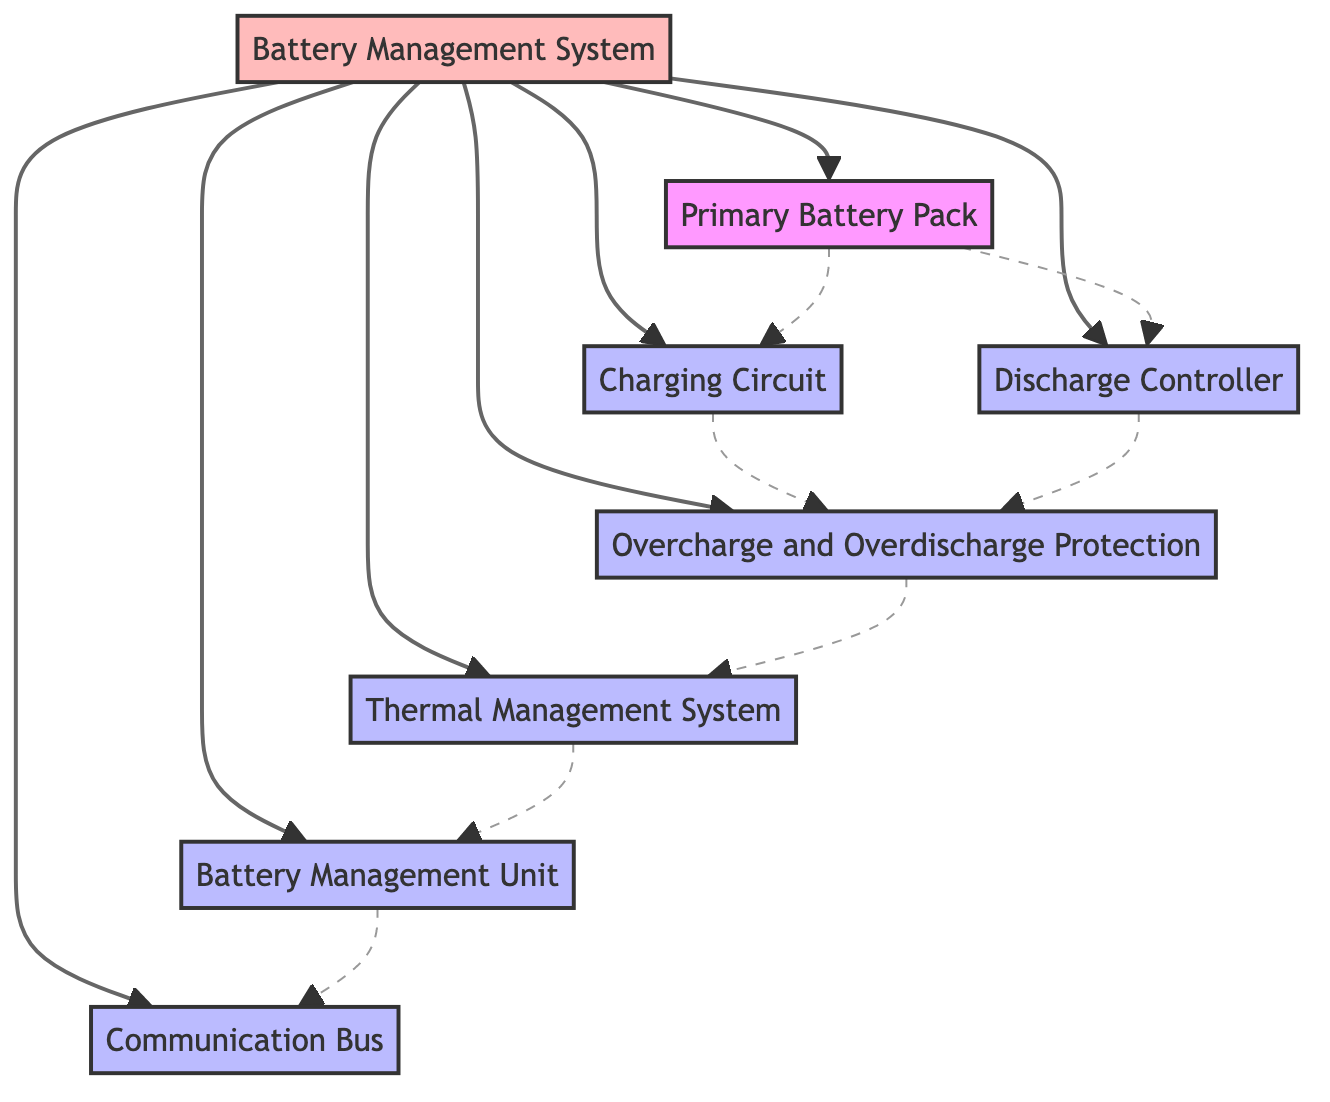What is the main power source in the Battery Management System? The diagram indicates the "Primary Battery Pack" as the main power source for the humanoid robot.
Answer: Primary Battery Pack How many modules are directly connected to the Battery Management System? From the diagram, six modules are directly connected to the Battery Management System: Charging Circuit, Discharge Controller, Overcharge and Overdischarge Protection, Thermal Management System, Battery Management Unit, and Communication Bus.
Answer: 6 Which module regulates energy flow from the battery? The diagram shows that the "Discharge Controller" is the module responsible for regulating energy flow from the battery to the robot's components.
Answer: Discharge Controller What prevents the battery from overcharging? The diagram specifies that the "Overcharge and Overdischarge Protection" module prevents the battery from overcharging.
Answer: Overcharge and Overdischarge Protection Name the module that monitors the battery's state. According to the diagram, the "Battery Management Unit (BMU)" is tasked with continuously monitoring the state of the battery.
Answer: Battery Management Unit (BMU) Which component communicates with other robot parts? The diagram illustrates that the "Communication Bus" facilitates data exchange between the battery management system and other components of the robot.
Answer: Communication Bus What is the relationship between the Charging Circuit and Overcharge and Overdischarge Protection? The diagram shows a dashed connection indicating that the Charging Circuit interacts with the Overcharge and Overdischarge Protection to ensure safety during charging.
Answer: Interact What role does the Thermal Management System play in the Battery Management System? The diagram indicates that the Thermal Management System monitors and controls the battery temperature to prevent overheating and ensure efficient operation.
Answer: Monitors and controls temperature How does the Battery Management Unit relate to the Communication Bus? The diagram demonstrates a dotted line connection, suggesting that the Battery Management Unit provides data to the Communication Bus for coordinated operation within the robot.
Answer: Provides data to 